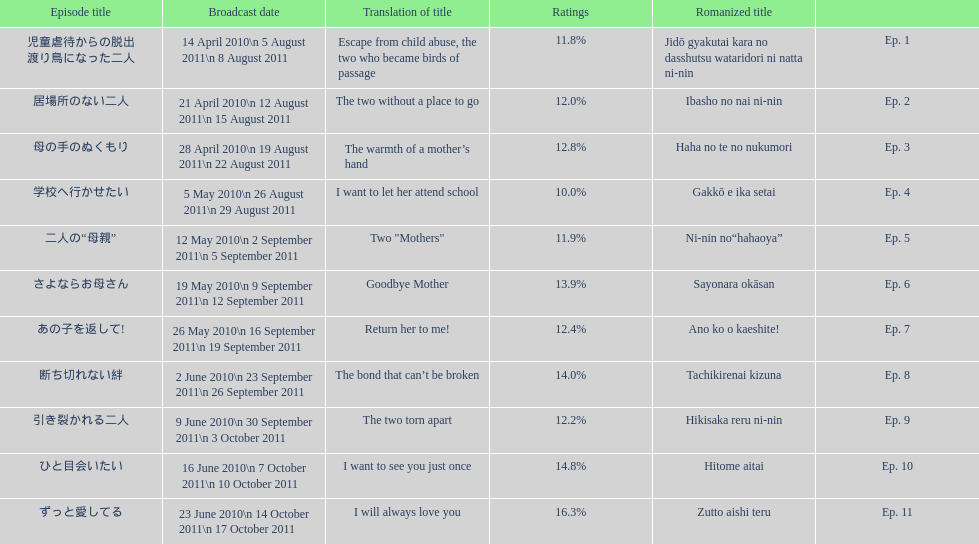How many episodes are listed? 11. 